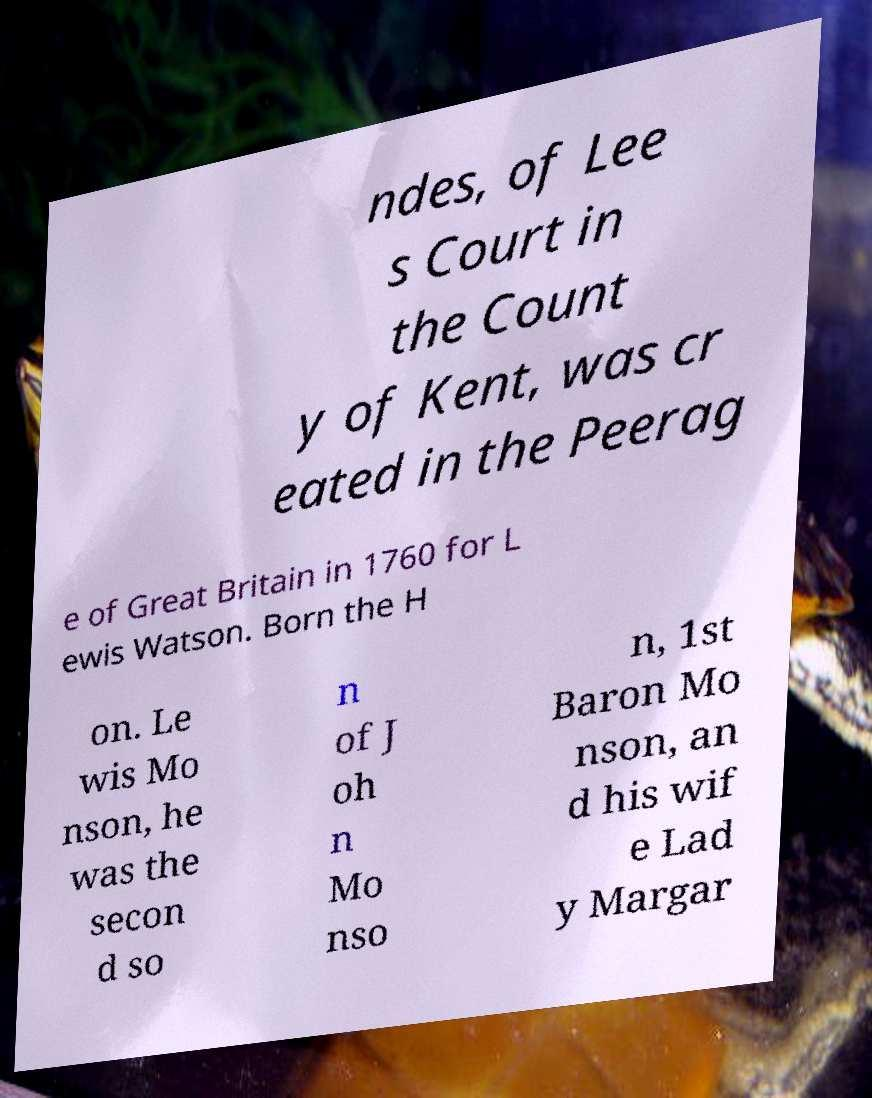Could you extract and type out the text from this image? ndes, of Lee s Court in the Count y of Kent, was cr eated in the Peerag e of Great Britain in 1760 for L ewis Watson. Born the H on. Le wis Mo nson, he was the secon d so n of J oh n Mo nso n, 1st Baron Mo nson, an d his wif e Lad y Margar 